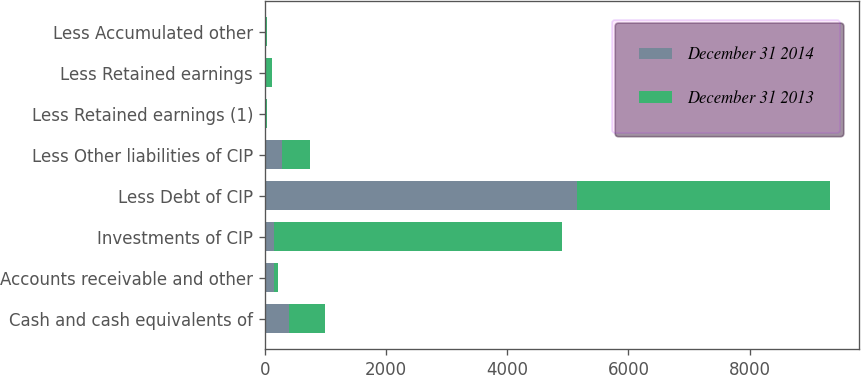<chart> <loc_0><loc_0><loc_500><loc_500><stacked_bar_chart><ecel><fcel>Cash and cash equivalents of<fcel>Accounts receivable and other<fcel>Investments of CIP<fcel>Less Debt of CIP<fcel>Less Other liabilities of CIP<fcel>Less Retained earnings (1)<fcel>Less Retained earnings<fcel>Less Accumulated other<nl><fcel>December 31 2014<fcel>404<fcel>161.3<fcel>161.3<fcel>5149.6<fcel>280.9<fcel>20.3<fcel>17.6<fcel>20.2<nl><fcel>December 31 2013<fcel>583.6<fcel>58.3<fcel>4734.7<fcel>4181.7<fcel>461.8<fcel>12.5<fcel>104.3<fcel>12.7<nl></chart> 